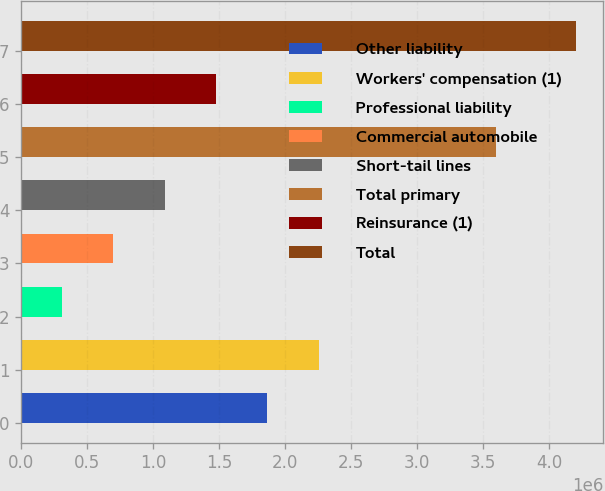Convert chart. <chart><loc_0><loc_0><loc_500><loc_500><bar_chart><fcel>Other liability<fcel>Workers' compensation (1)<fcel>Professional liability<fcel>Commercial automobile<fcel>Short-tail lines<fcel>Total primary<fcel>Reinsurance (1)<fcel>Total<nl><fcel>1.86581e+06<fcel>2.25504e+06<fcel>308887<fcel>698118<fcel>1.08735e+06<fcel>3.59735e+06<fcel>1.47658e+06<fcel>4.2012e+06<nl></chart> 